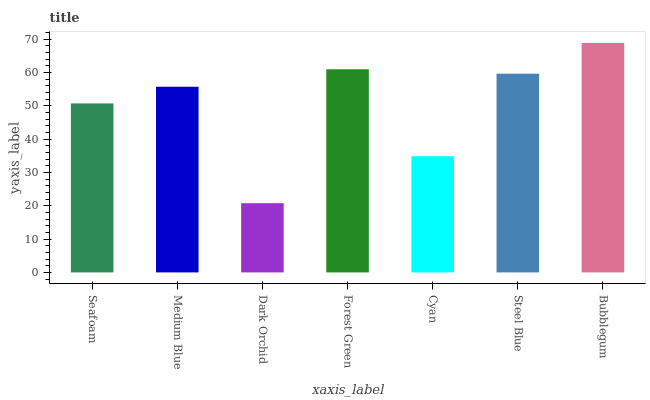Is Dark Orchid the minimum?
Answer yes or no. Yes. Is Bubblegum the maximum?
Answer yes or no. Yes. Is Medium Blue the minimum?
Answer yes or no. No. Is Medium Blue the maximum?
Answer yes or no. No. Is Medium Blue greater than Seafoam?
Answer yes or no. Yes. Is Seafoam less than Medium Blue?
Answer yes or no. Yes. Is Seafoam greater than Medium Blue?
Answer yes or no. No. Is Medium Blue less than Seafoam?
Answer yes or no. No. Is Medium Blue the high median?
Answer yes or no. Yes. Is Medium Blue the low median?
Answer yes or no. Yes. Is Dark Orchid the high median?
Answer yes or no. No. Is Bubblegum the low median?
Answer yes or no. No. 